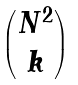<formula> <loc_0><loc_0><loc_500><loc_500>\begin{pmatrix} N ^ { 2 } \\ k \end{pmatrix}</formula> 